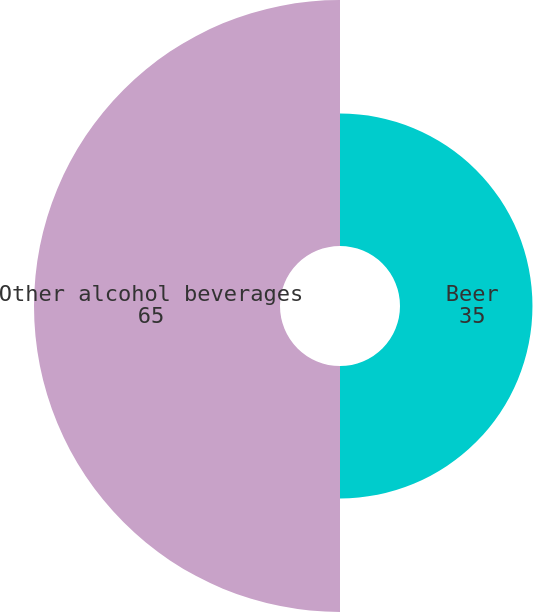Convert chart. <chart><loc_0><loc_0><loc_500><loc_500><pie_chart><fcel>Beer<fcel>Other alcohol beverages<nl><fcel>35.0%<fcel>65.0%<nl></chart> 